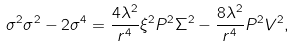Convert formula to latex. <formula><loc_0><loc_0><loc_500><loc_500>\sigma ^ { 2 } \sigma ^ { 2 } - 2 \sigma ^ { 4 } = \frac { 4 \lambda ^ { 2 } } { r ^ { 4 } } \xi ^ { 2 } P ^ { 2 } \Sigma ^ { 2 } - \frac { 8 \lambda ^ { 2 } } { r ^ { 4 } } P ^ { 2 } V ^ { 2 } ,</formula> 